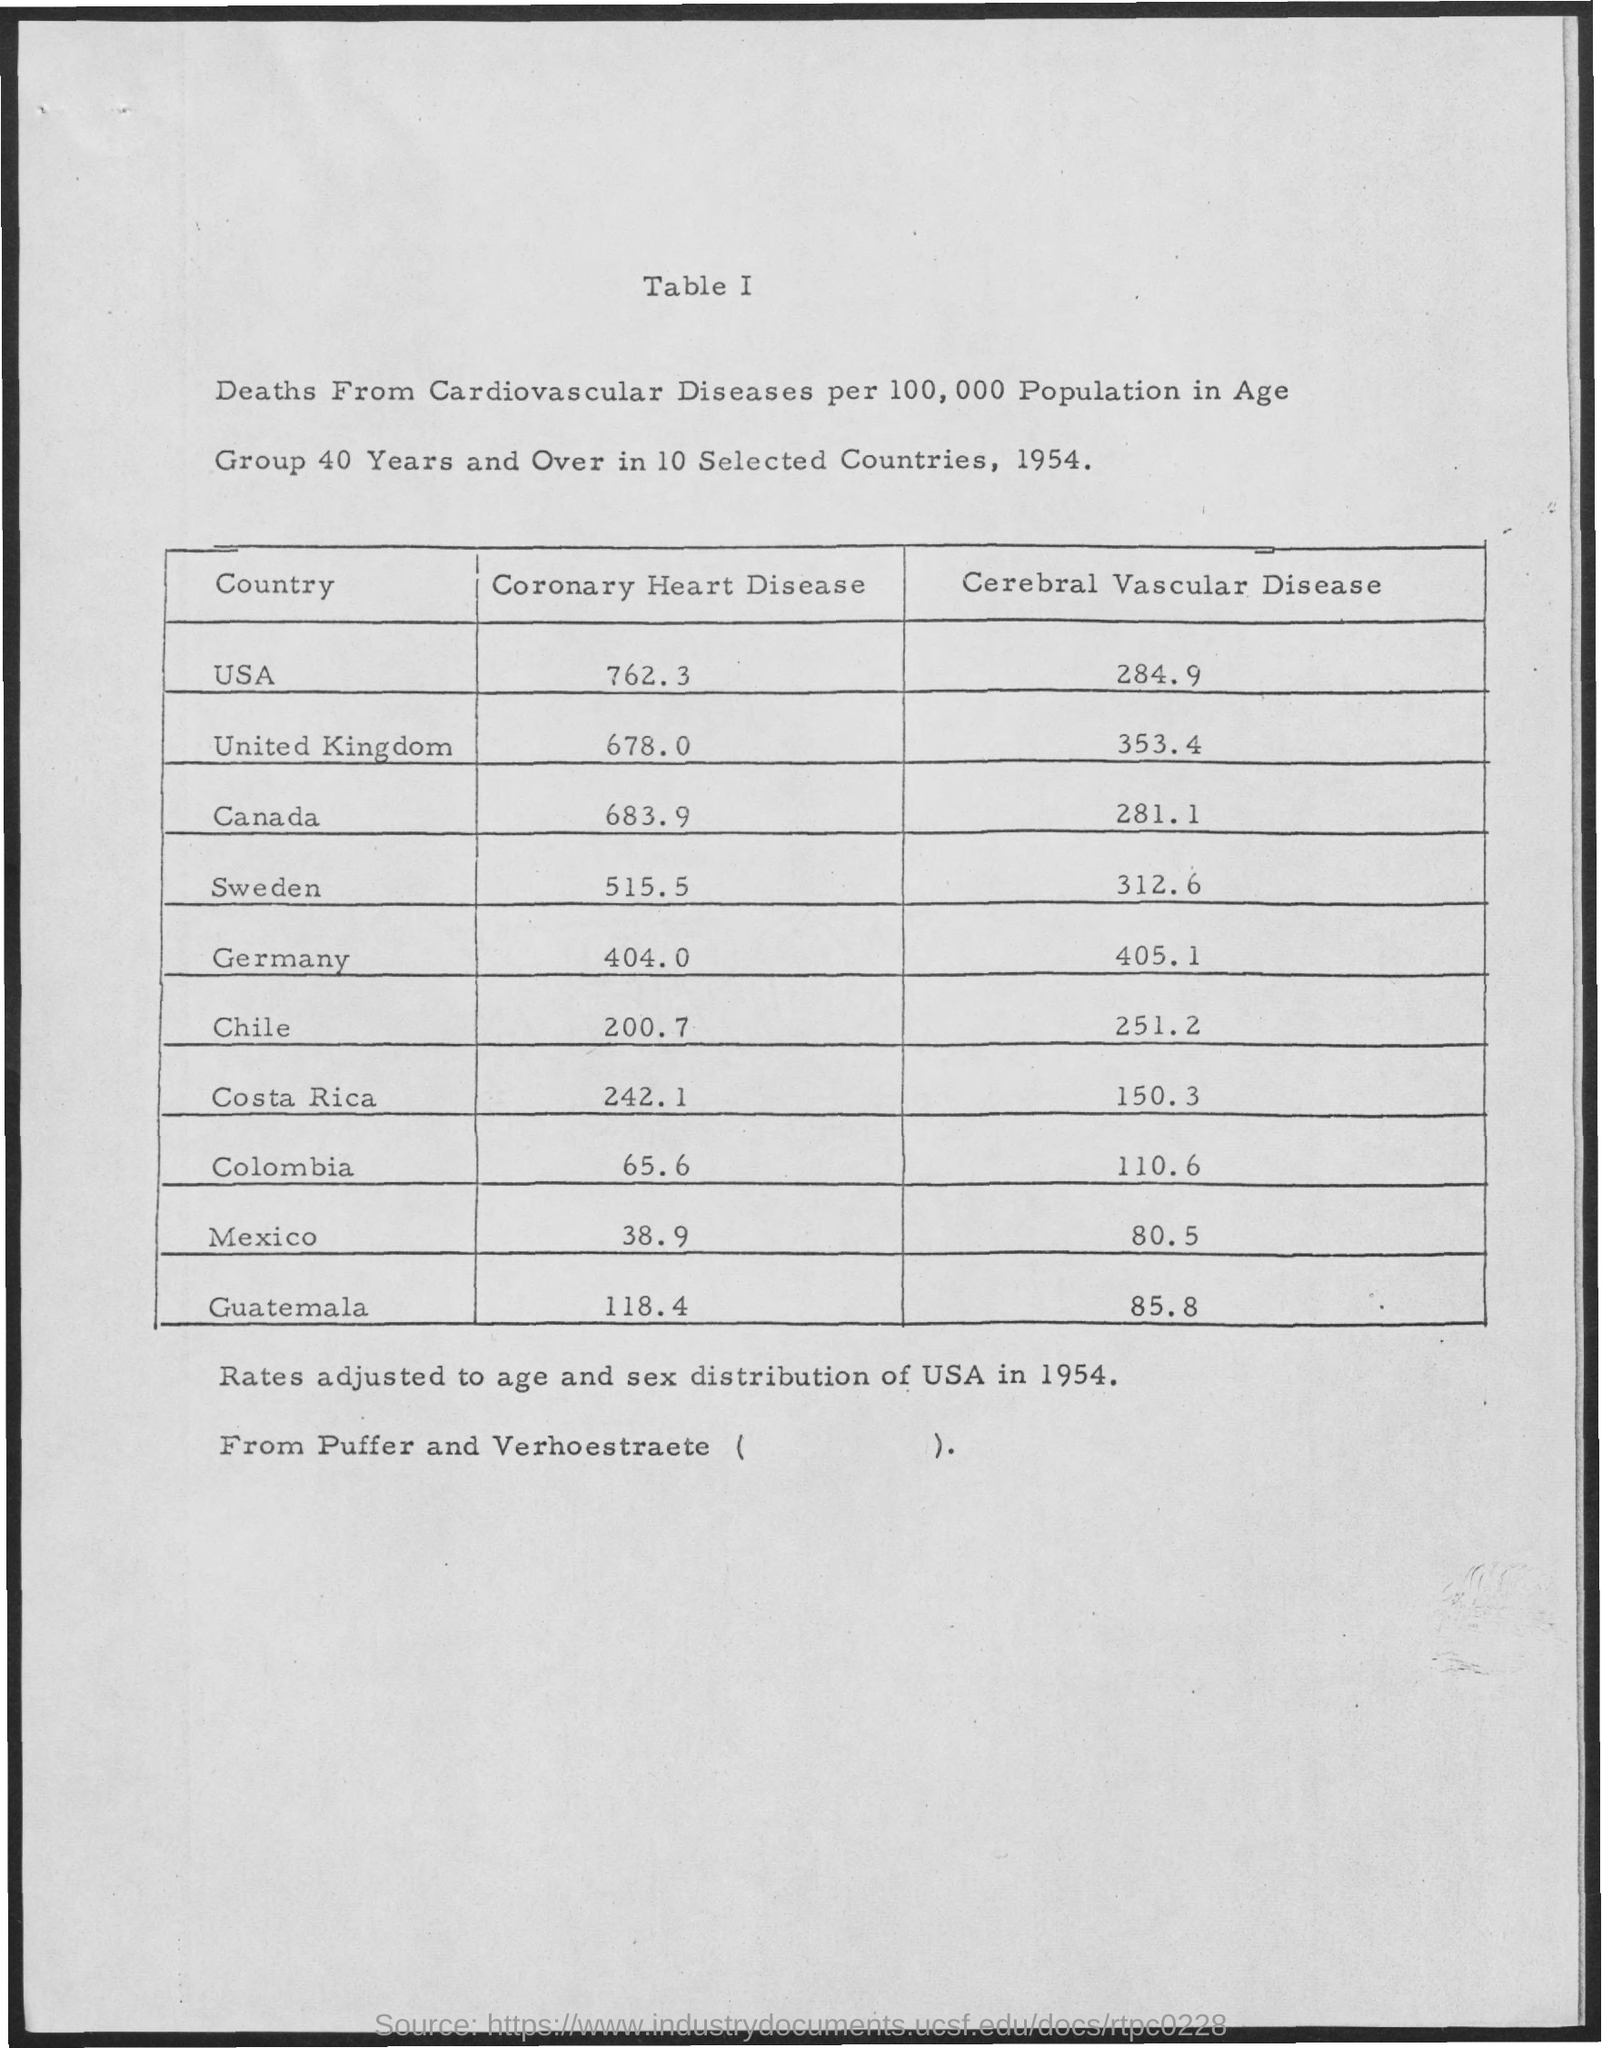Outline some significant characteristics in this image. The letterhead contains the text 'Table I.' 